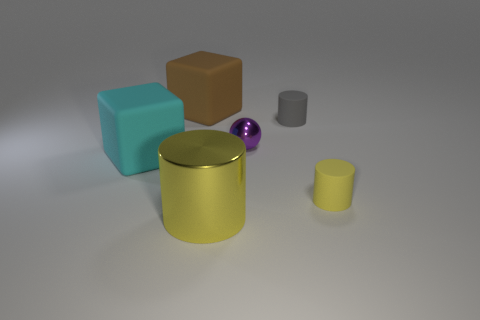Subtract all yellow cylinders. How many cylinders are left? 1 Subtract all brown blocks. How many yellow cylinders are left? 2 Add 4 small purple shiny objects. How many objects exist? 10 Subtract all green cylinders. Subtract all brown cubes. How many cylinders are left? 3 Subtract all spheres. How many objects are left? 5 Subtract all big purple blocks. Subtract all purple metal balls. How many objects are left? 5 Add 5 big yellow cylinders. How many big yellow cylinders are left? 6 Add 4 gray shiny balls. How many gray shiny balls exist? 4 Subtract 0 yellow blocks. How many objects are left? 6 